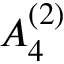Convert formula to latex. <formula><loc_0><loc_0><loc_500><loc_500>{ A } _ { 4 } ^ { ( 2 ) }</formula> 